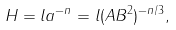<formula> <loc_0><loc_0><loc_500><loc_500>H = l a ^ { - n } = l ( A B ^ { 2 } ) ^ { - n / 3 } ,</formula> 